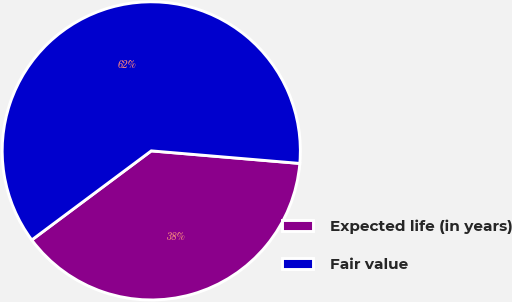Convert chart to OTSL. <chart><loc_0><loc_0><loc_500><loc_500><pie_chart><fcel>Expected life (in years)<fcel>Fair value<nl><fcel>38.46%<fcel>61.54%<nl></chart> 